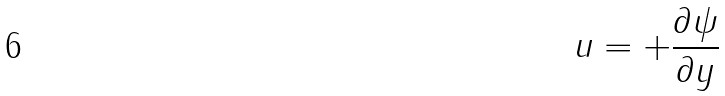<formula> <loc_0><loc_0><loc_500><loc_500>u = + \frac { \partial \psi } { \partial y }</formula> 